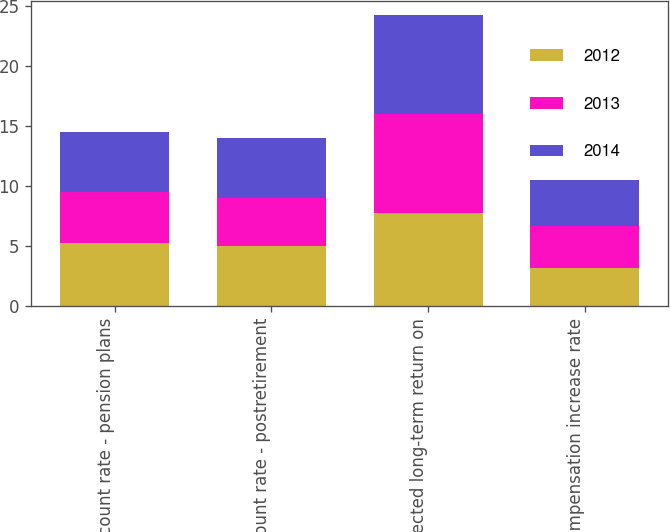Convert chart to OTSL. <chart><loc_0><loc_0><loc_500><loc_500><stacked_bar_chart><ecel><fcel>Discount rate - pension plans<fcel>Discount rate - postretirement<fcel>Expected long-term return on<fcel>Compensation increase rate<nl><fcel>2012<fcel>5.25<fcel>5<fcel>7.75<fcel>3.2<nl><fcel>2013<fcel>4.25<fcel>4<fcel>8.25<fcel>3.5<nl><fcel>2014<fcel>5<fcel>5<fcel>8.25<fcel>3.8<nl></chart> 